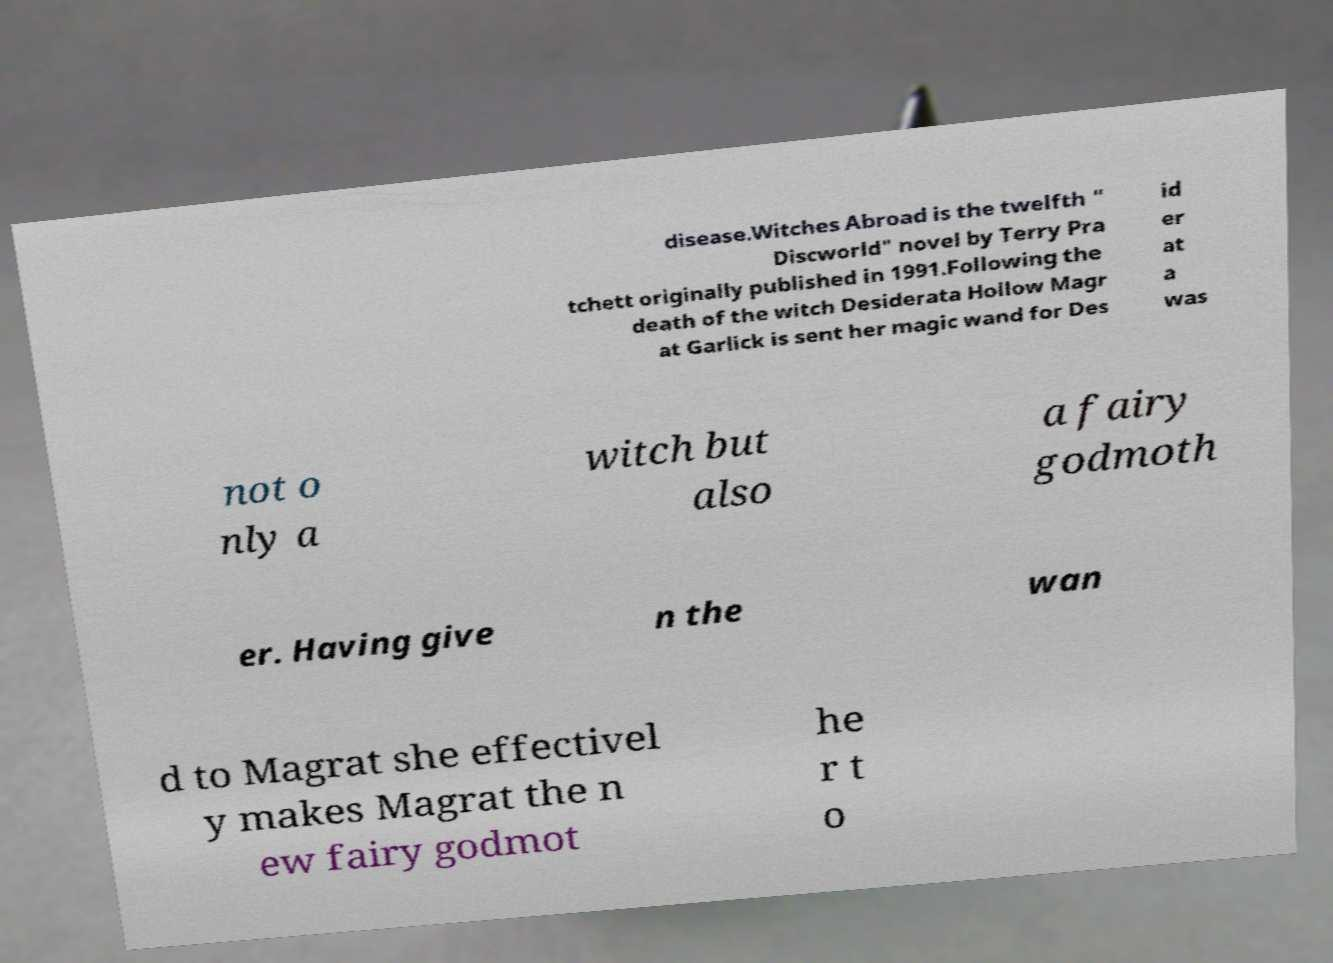Can you read and provide the text displayed in the image?This photo seems to have some interesting text. Can you extract and type it out for me? disease.Witches Abroad is the twelfth " Discworld" novel by Terry Pra tchett originally published in 1991.Following the death of the witch Desiderata Hollow Magr at Garlick is sent her magic wand for Des id er at a was not o nly a witch but also a fairy godmoth er. Having give n the wan d to Magrat she effectivel y makes Magrat the n ew fairy godmot he r t o 